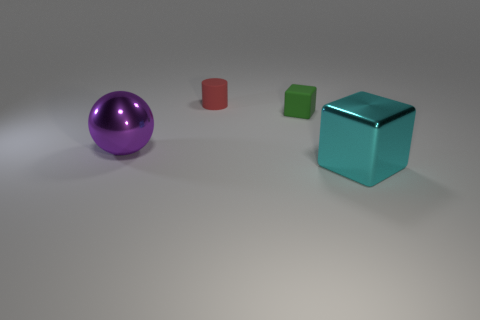What mood or atmosphere does the arrangement of these objects convey? The arrangement of objects within the image conveys a serene and orderly atmosphere devoid of any chaotic elements. There's a sense of simplicity and minimalism due to the clear space around each object. The muted colors and uniform lighting also contribute to a calm and neutral mood. This setting might be used to draw attention to the individual characteristics of each object without the distraction of a complex environment. 